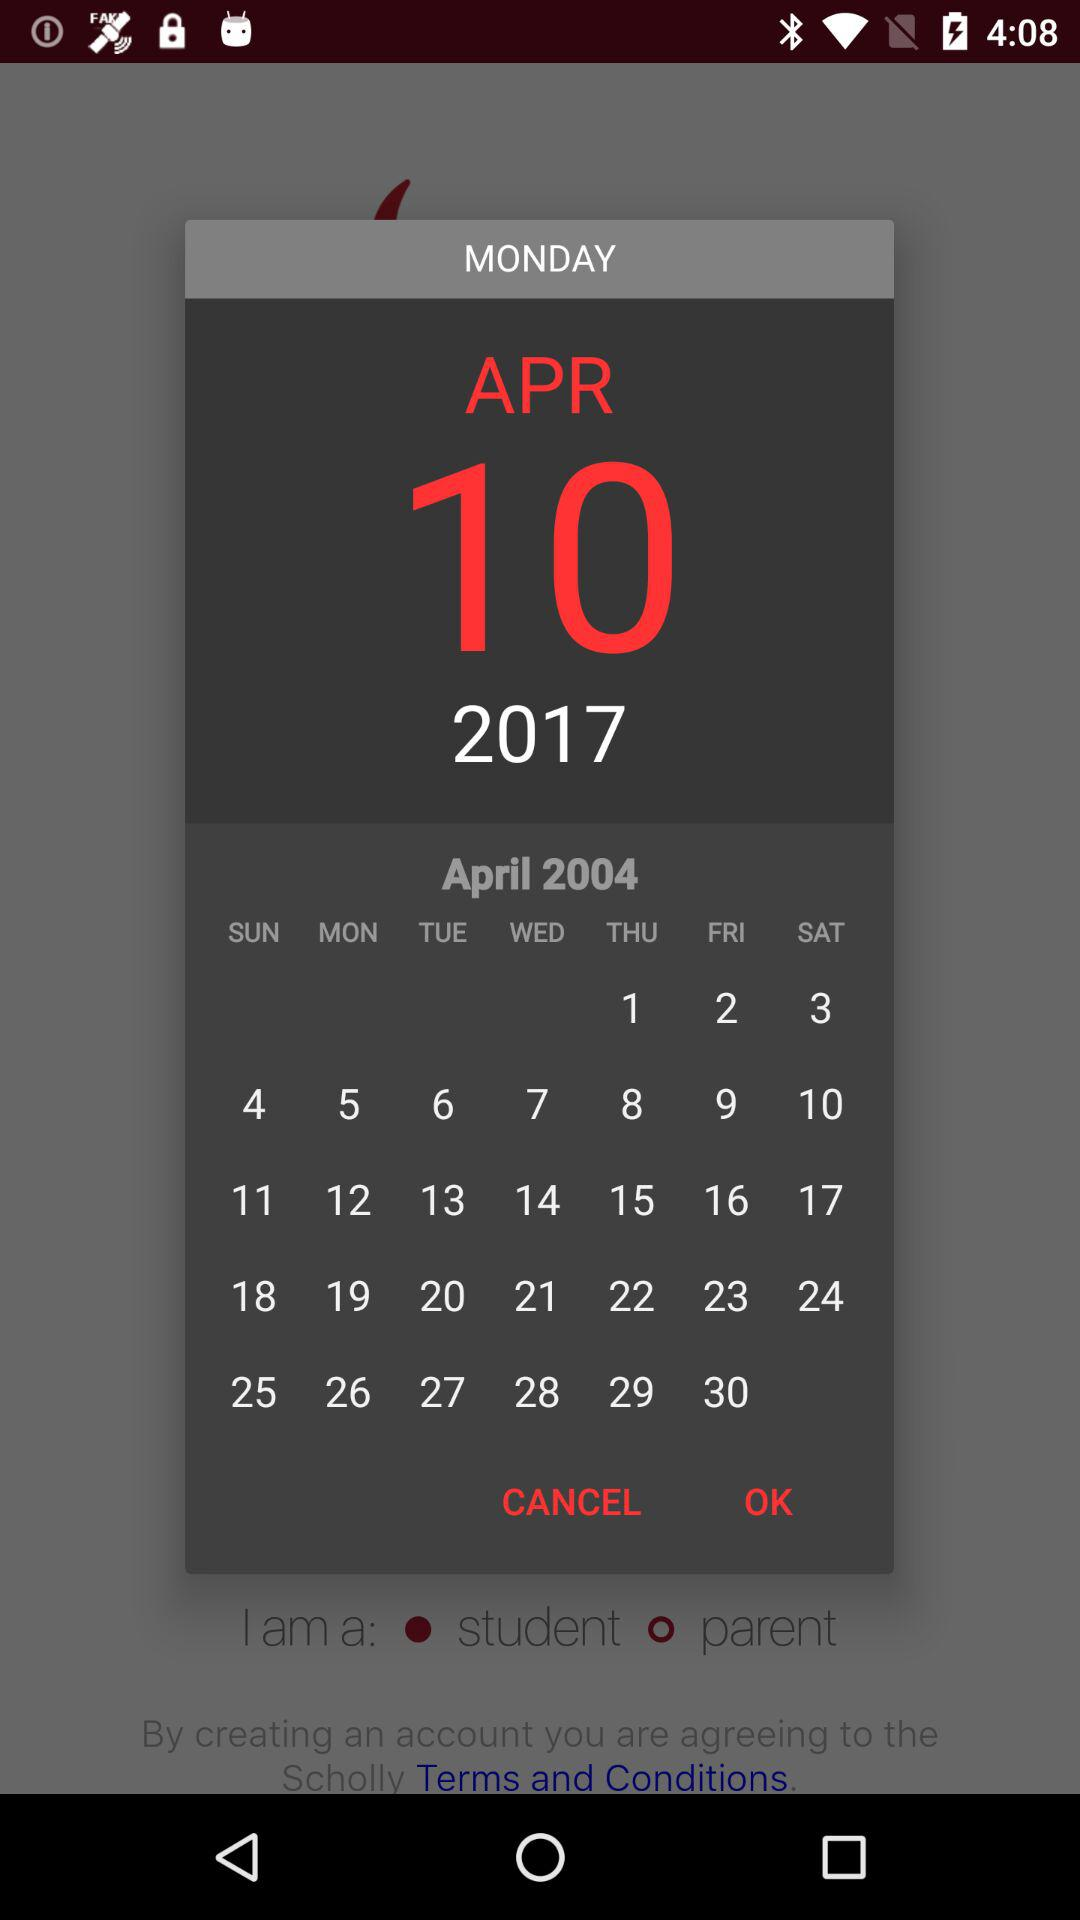Which day is it on April 1, 2004? The day is Thursday. 